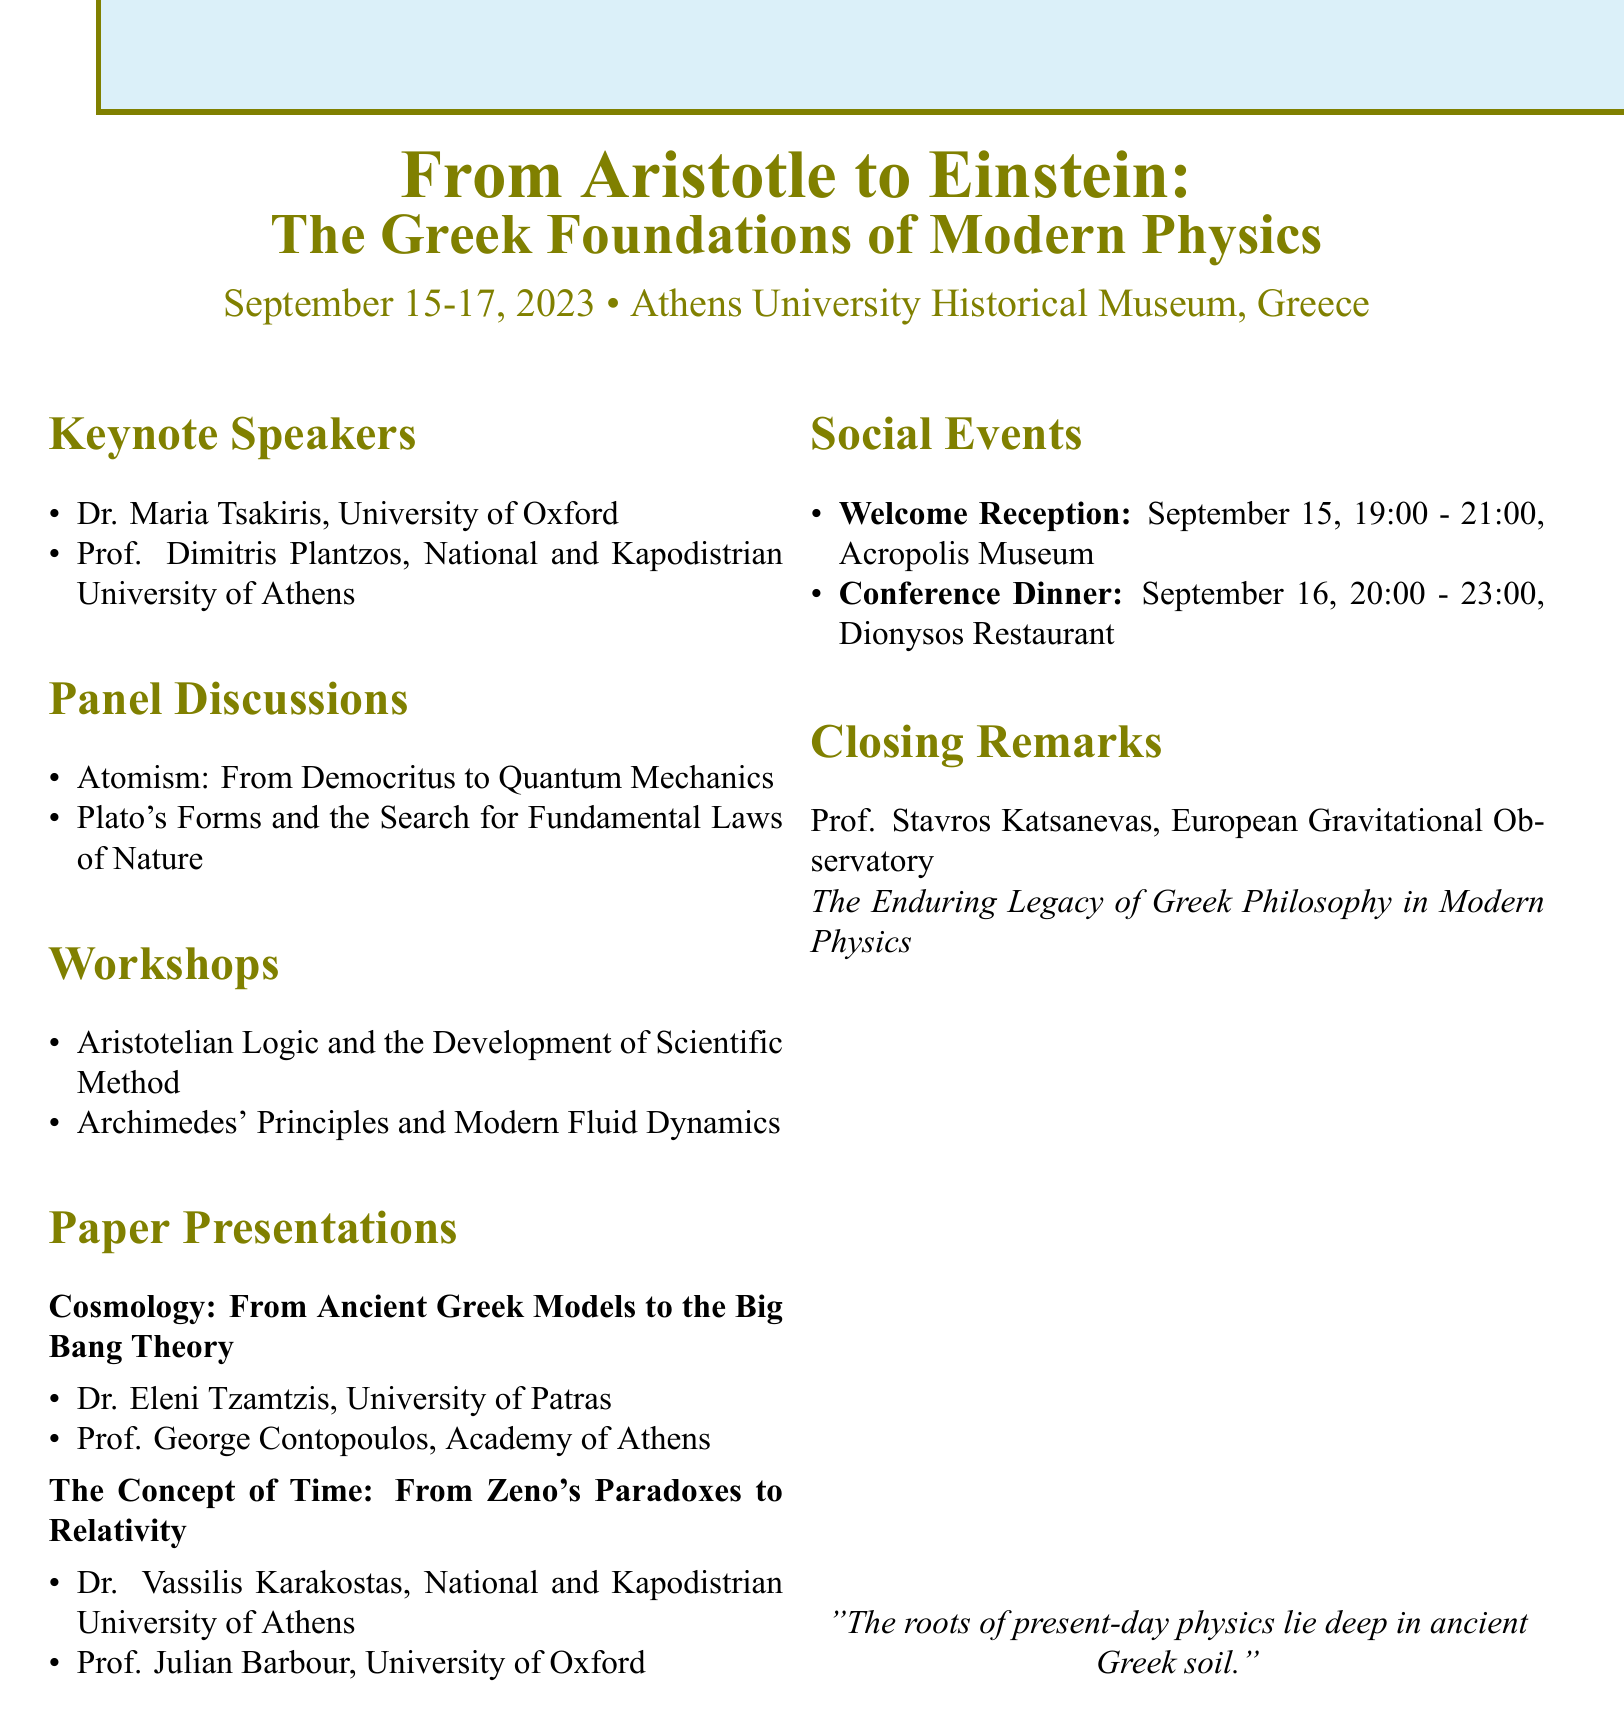What are the dates of the conference? The dates of the conference are specified as September 15-17, 2023.
Answer: September 15-17, 2023 Who is the keynote speaker affiliated with the University of Oxford? The document lists Dr. Maria Tsakiris as the keynote speaker from the University of Oxford.
Answer: Dr. Maria Tsakiris What is the title of the workshop facilitated by Prof. Constantinos Evangelinos? The title of the workshop facilitated by Prof. Constantinos Evangelinos is included in the document as "Archimedes' Principles and Modern Fluid Dynamics."
Answer: Archimedes' Principles and Modern Fluid Dynamics Who is moderating the panel discussion on Atomism? The document specifies that Dr. Panagiotis Papaspirou is moderating the panel discussion on Atomism.
Answer: Dr. Panagiotis Papaspirou What venue is hosting the welcome reception? The venue for the welcome reception is mentioned as the Acropolis Museum.
Answer: Acropolis Museum How many keynote speakers are listed in the agenda? The agenda lists a total of two keynote speakers.
Answer: 2 